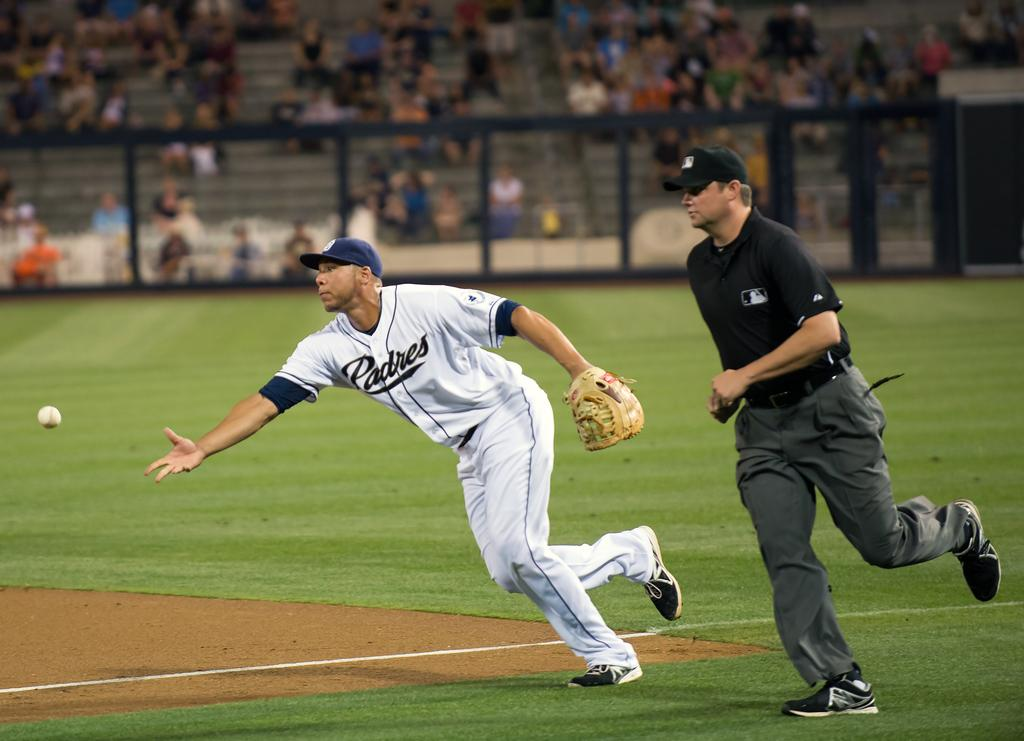<image>
Relay a brief, clear account of the picture shown. A man with the word Padres on his shirt throws a baseball. 